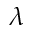<formula> <loc_0><loc_0><loc_500><loc_500>\lambda</formula> 